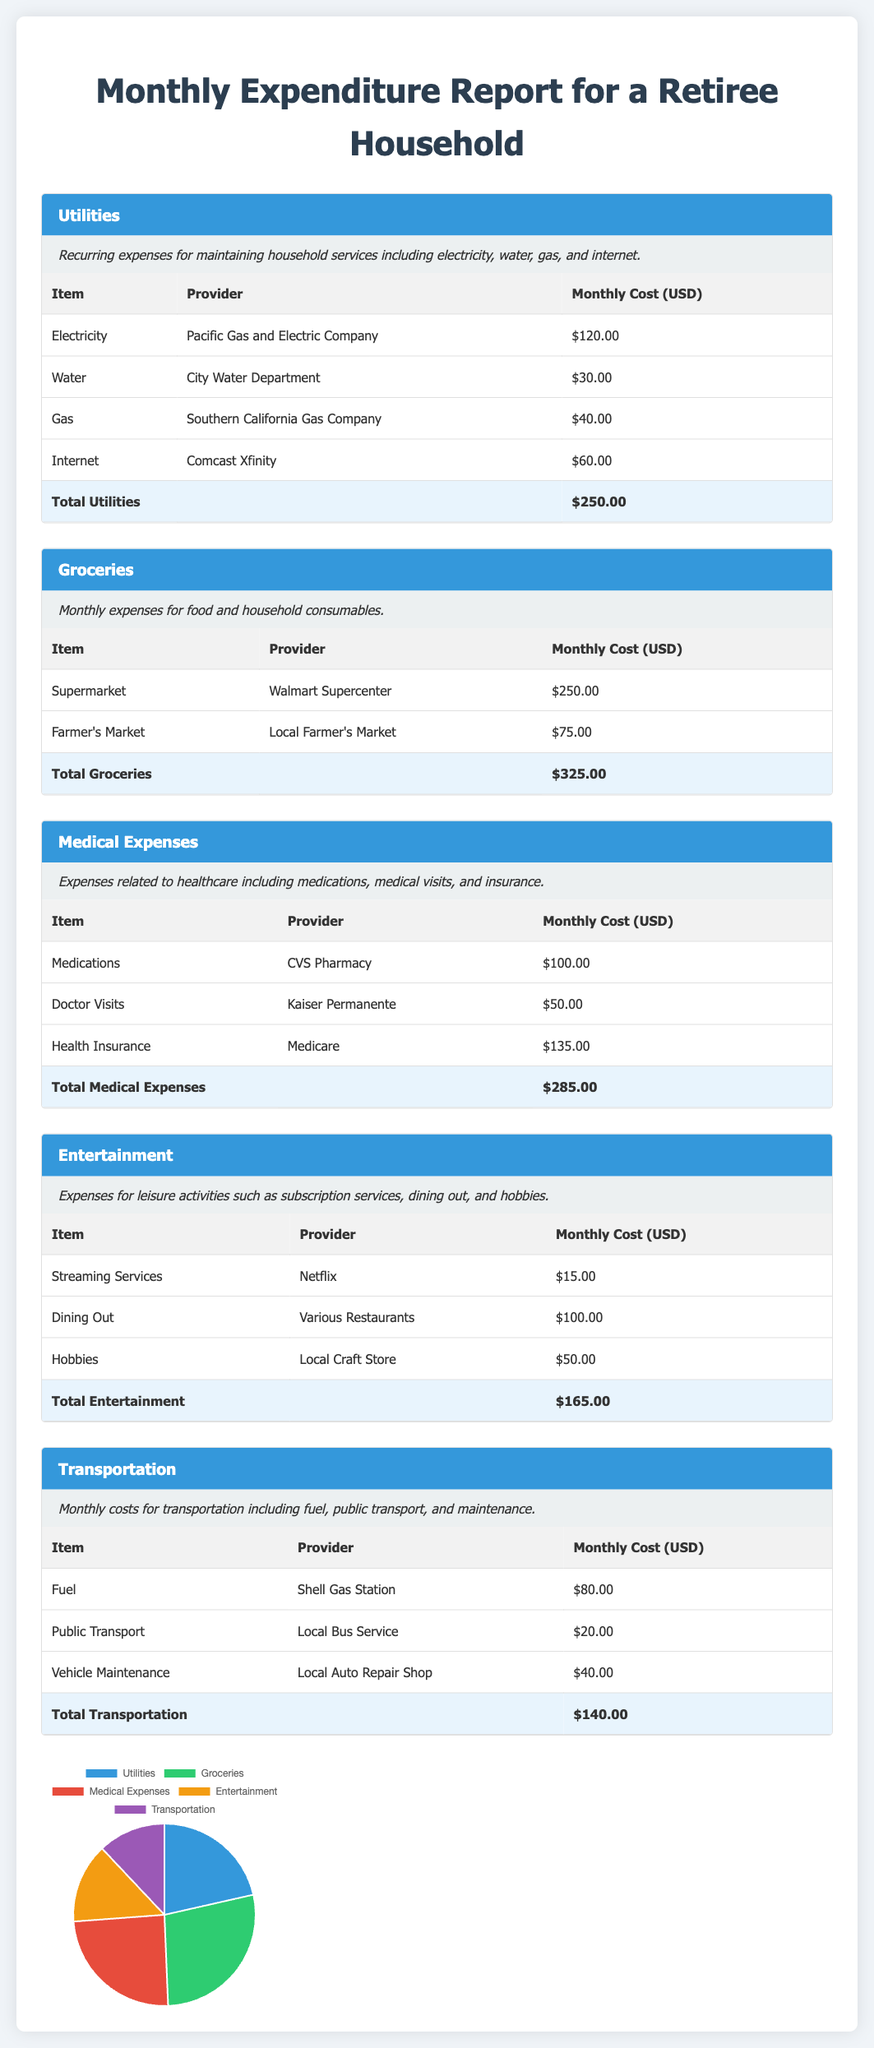what is the total cost for Utilities? The total cost for Utilities is provided in the utilities section of the document, which is $250.00.
Answer: $250.00 what is the monthly expense for Groceries at Walmart Supercenter? The monthly expense for Groceries at Walmart Supercenter is listed in the groceries table, which is $250.00.
Answer: $250.00 which provider supplies the health insurance? The provider for health insurance is mentioned in the medical expenses section, which is Medicare.
Answer: Medicare what is the total monthly expenditure for Medical Expenses? The total monthly expenditure for Medical Expenses is indicated in the medical expenses table, which is $285.00.
Answer: $285.00 how much is spent on Entertainment for dining out? The expenditure for dining out in the entertainment section is stated, which is $100.00.
Answer: $100.00 which category has the highest monthly expense? Comparing the total expenses across categories, Groceries has the highest cost at $325.00.
Answer: Groceries what is the total amount spent on Transportation? The total amount for Transportation is specified in that section of the document, which is $140.00.
Answer: $140.00 how much does the local bus service charge monthly? The monthly charge for the local bus service is listed in the transportation table, which is $20.00.
Answer: $20.00 what is the primary category of recurring household services? The primary category of recurring household services is Utilities, which includes expenses like electricity, water, gas, and internet.
Answer: Utilities 